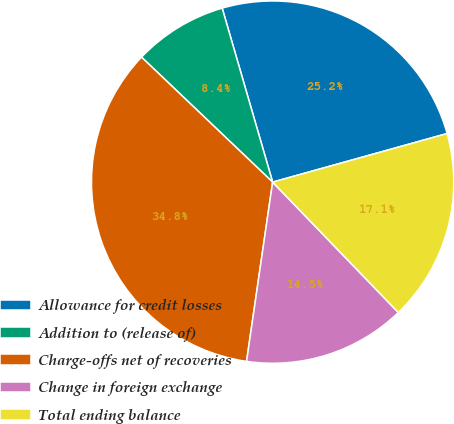Convert chart to OTSL. <chart><loc_0><loc_0><loc_500><loc_500><pie_chart><fcel>Allowance for credit losses<fcel>Addition to (release of)<fcel>Charge-offs net of recoveries<fcel>Change in foreign exchange<fcel>Total ending balance<nl><fcel>25.17%<fcel>8.39%<fcel>34.82%<fcel>14.51%<fcel>17.11%<nl></chart> 